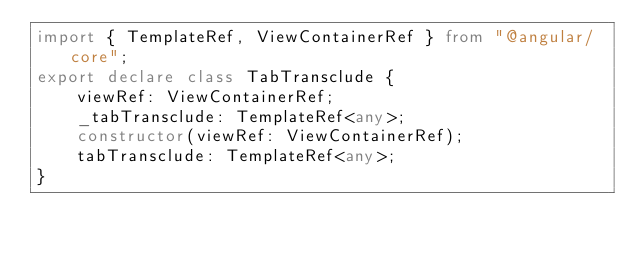<code> <loc_0><loc_0><loc_500><loc_500><_TypeScript_>import { TemplateRef, ViewContainerRef } from "@angular/core";
export declare class TabTransclude {
    viewRef: ViewContainerRef;
    _tabTransclude: TemplateRef<any>;
    constructor(viewRef: ViewContainerRef);
    tabTransclude: TemplateRef<any>;
}
</code> 